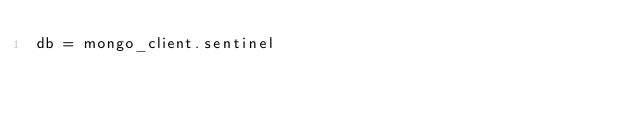Convert code to text. <code><loc_0><loc_0><loc_500><loc_500><_Python_>db = mongo_client.sentinel
</code> 